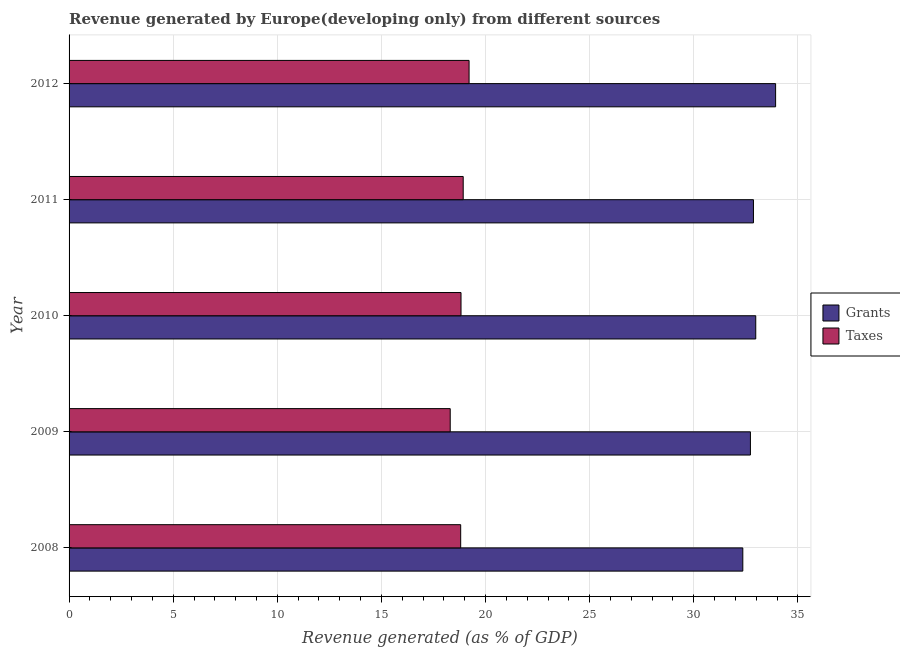How many different coloured bars are there?
Make the answer very short. 2. How many groups of bars are there?
Keep it short and to the point. 5. Are the number of bars per tick equal to the number of legend labels?
Give a very brief answer. Yes. How many bars are there on the 4th tick from the bottom?
Ensure brevity in your answer.  2. What is the label of the 5th group of bars from the top?
Make the answer very short. 2008. What is the revenue generated by taxes in 2012?
Ensure brevity in your answer.  19.21. Across all years, what is the maximum revenue generated by grants?
Your response must be concise. 33.93. Across all years, what is the minimum revenue generated by taxes?
Provide a succinct answer. 18.3. What is the total revenue generated by taxes in the graph?
Keep it short and to the point. 94.07. What is the difference between the revenue generated by taxes in 2008 and that in 2012?
Keep it short and to the point. -0.4. What is the difference between the revenue generated by grants in 2009 and the revenue generated by taxes in 2012?
Keep it short and to the point. 13.51. What is the average revenue generated by grants per year?
Your response must be concise. 32.97. In the year 2012, what is the difference between the revenue generated by taxes and revenue generated by grants?
Your response must be concise. -14.72. What is the ratio of the revenue generated by taxes in 2009 to that in 2012?
Provide a short and direct response. 0.95. What is the difference between the highest and the second highest revenue generated by taxes?
Ensure brevity in your answer.  0.28. What is the difference between the highest and the lowest revenue generated by taxes?
Provide a short and direct response. 0.91. In how many years, is the revenue generated by taxes greater than the average revenue generated by taxes taken over all years?
Offer a very short reply. 3. What does the 2nd bar from the top in 2009 represents?
Offer a terse response. Grants. What does the 2nd bar from the bottom in 2008 represents?
Offer a terse response. Taxes. How many years are there in the graph?
Offer a very short reply. 5. What is the difference between two consecutive major ticks on the X-axis?
Offer a terse response. 5. Where does the legend appear in the graph?
Keep it short and to the point. Center right. How many legend labels are there?
Provide a succinct answer. 2. How are the legend labels stacked?
Offer a very short reply. Vertical. What is the title of the graph?
Keep it short and to the point. Revenue generated by Europe(developing only) from different sources. Does "State government" appear as one of the legend labels in the graph?
Offer a terse response. No. What is the label or title of the X-axis?
Give a very brief answer. Revenue generated (as % of GDP). What is the Revenue generated (as % of GDP) in Grants in 2008?
Make the answer very short. 32.35. What is the Revenue generated (as % of GDP) of Taxes in 2008?
Offer a very short reply. 18.81. What is the Revenue generated (as % of GDP) in Grants in 2009?
Give a very brief answer. 32.72. What is the Revenue generated (as % of GDP) in Taxes in 2009?
Keep it short and to the point. 18.3. What is the Revenue generated (as % of GDP) of Grants in 2010?
Keep it short and to the point. 32.98. What is the Revenue generated (as % of GDP) in Taxes in 2010?
Your answer should be very brief. 18.82. What is the Revenue generated (as % of GDP) of Grants in 2011?
Your answer should be very brief. 32.87. What is the Revenue generated (as % of GDP) of Taxes in 2011?
Provide a succinct answer. 18.93. What is the Revenue generated (as % of GDP) of Grants in 2012?
Your answer should be very brief. 33.93. What is the Revenue generated (as % of GDP) in Taxes in 2012?
Offer a terse response. 19.21. Across all years, what is the maximum Revenue generated (as % of GDP) of Grants?
Provide a short and direct response. 33.93. Across all years, what is the maximum Revenue generated (as % of GDP) in Taxes?
Offer a very short reply. 19.21. Across all years, what is the minimum Revenue generated (as % of GDP) in Grants?
Make the answer very short. 32.35. Across all years, what is the minimum Revenue generated (as % of GDP) in Taxes?
Your answer should be compact. 18.3. What is the total Revenue generated (as % of GDP) of Grants in the graph?
Ensure brevity in your answer.  164.85. What is the total Revenue generated (as % of GDP) in Taxes in the graph?
Make the answer very short. 94.07. What is the difference between the Revenue generated (as % of GDP) in Grants in 2008 and that in 2009?
Your answer should be very brief. -0.37. What is the difference between the Revenue generated (as % of GDP) of Taxes in 2008 and that in 2009?
Keep it short and to the point. 0.5. What is the difference between the Revenue generated (as % of GDP) in Grants in 2008 and that in 2010?
Offer a terse response. -0.62. What is the difference between the Revenue generated (as % of GDP) in Taxes in 2008 and that in 2010?
Offer a very short reply. -0.02. What is the difference between the Revenue generated (as % of GDP) of Grants in 2008 and that in 2011?
Give a very brief answer. -0.51. What is the difference between the Revenue generated (as % of GDP) in Taxes in 2008 and that in 2011?
Offer a terse response. -0.12. What is the difference between the Revenue generated (as % of GDP) of Grants in 2008 and that in 2012?
Your answer should be compact. -1.57. What is the difference between the Revenue generated (as % of GDP) in Taxes in 2008 and that in 2012?
Your answer should be compact. -0.4. What is the difference between the Revenue generated (as % of GDP) of Grants in 2009 and that in 2010?
Provide a succinct answer. -0.26. What is the difference between the Revenue generated (as % of GDP) of Taxes in 2009 and that in 2010?
Give a very brief answer. -0.52. What is the difference between the Revenue generated (as % of GDP) in Grants in 2009 and that in 2011?
Your answer should be very brief. -0.15. What is the difference between the Revenue generated (as % of GDP) of Taxes in 2009 and that in 2011?
Give a very brief answer. -0.62. What is the difference between the Revenue generated (as % of GDP) of Grants in 2009 and that in 2012?
Your response must be concise. -1.21. What is the difference between the Revenue generated (as % of GDP) of Taxes in 2009 and that in 2012?
Provide a succinct answer. -0.91. What is the difference between the Revenue generated (as % of GDP) in Grants in 2010 and that in 2011?
Ensure brevity in your answer.  0.11. What is the difference between the Revenue generated (as % of GDP) in Taxes in 2010 and that in 2011?
Keep it short and to the point. -0.1. What is the difference between the Revenue generated (as % of GDP) in Grants in 2010 and that in 2012?
Give a very brief answer. -0.95. What is the difference between the Revenue generated (as % of GDP) in Taxes in 2010 and that in 2012?
Your answer should be very brief. -0.39. What is the difference between the Revenue generated (as % of GDP) of Grants in 2011 and that in 2012?
Offer a terse response. -1.06. What is the difference between the Revenue generated (as % of GDP) of Taxes in 2011 and that in 2012?
Offer a very short reply. -0.28. What is the difference between the Revenue generated (as % of GDP) in Grants in 2008 and the Revenue generated (as % of GDP) in Taxes in 2009?
Offer a very short reply. 14.05. What is the difference between the Revenue generated (as % of GDP) in Grants in 2008 and the Revenue generated (as % of GDP) in Taxes in 2010?
Provide a short and direct response. 13.53. What is the difference between the Revenue generated (as % of GDP) in Grants in 2008 and the Revenue generated (as % of GDP) in Taxes in 2011?
Provide a short and direct response. 13.43. What is the difference between the Revenue generated (as % of GDP) in Grants in 2008 and the Revenue generated (as % of GDP) in Taxes in 2012?
Give a very brief answer. 13.15. What is the difference between the Revenue generated (as % of GDP) in Grants in 2009 and the Revenue generated (as % of GDP) in Taxes in 2010?
Your answer should be very brief. 13.9. What is the difference between the Revenue generated (as % of GDP) in Grants in 2009 and the Revenue generated (as % of GDP) in Taxes in 2011?
Provide a short and direct response. 13.79. What is the difference between the Revenue generated (as % of GDP) of Grants in 2009 and the Revenue generated (as % of GDP) of Taxes in 2012?
Provide a succinct answer. 13.51. What is the difference between the Revenue generated (as % of GDP) in Grants in 2010 and the Revenue generated (as % of GDP) in Taxes in 2011?
Offer a very short reply. 14.05. What is the difference between the Revenue generated (as % of GDP) in Grants in 2010 and the Revenue generated (as % of GDP) in Taxes in 2012?
Offer a very short reply. 13.77. What is the difference between the Revenue generated (as % of GDP) of Grants in 2011 and the Revenue generated (as % of GDP) of Taxes in 2012?
Provide a short and direct response. 13.66. What is the average Revenue generated (as % of GDP) of Grants per year?
Give a very brief answer. 32.97. What is the average Revenue generated (as % of GDP) in Taxes per year?
Your answer should be compact. 18.81. In the year 2008, what is the difference between the Revenue generated (as % of GDP) in Grants and Revenue generated (as % of GDP) in Taxes?
Your answer should be compact. 13.55. In the year 2009, what is the difference between the Revenue generated (as % of GDP) of Grants and Revenue generated (as % of GDP) of Taxes?
Your response must be concise. 14.42. In the year 2010, what is the difference between the Revenue generated (as % of GDP) of Grants and Revenue generated (as % of GDP) of Taxes?
Make the answer very short. 14.15. In the year 2011, what is the difference between the Revenue generated (as % of GDP) of Grants and Revenue generated (as % of GDP) of Taxes?
Your response must be concise. 13.94. In the year 2012, what is the difference between the Revenue generated (as % of GDP) of Grants and Revenue generated (as % of GDP) of Taxes?
Ensure brevity in your answer.  14.72. What is the ratio of the Revenue generated (as % of GDP) of Grants in 2008 to that in 2009?
Give a very brief answer. 0.99. What is the ratio of the Revenue generated (as % of GDP) of Taxes in 2008 to that in 2009?
Make the answer very short. 1.03. What is the ratio of the Revenue generated (as % of GDP) of Grants in 2008 to that in 2010?
Keep it short and to the point. 0.98. What is the ratio of the Revenue generated (as % of GDP) of Taxes in 2008 to that in 2010?
Your answer should be compact. 1. What is the ratio of the Revenue generated (as % of GDP) in Grants in 2008 to that in 2011?
Provide a succinct answer. 0.98. What is the ratio of the Revenue generated (as % of GDP) of Grants in 2008 to that in 2012?
Make the answer very short. 0.95. What is the ratio of the Revenue generated (as % of GDP) in Taxes in 2008 to that in 2012?
Keep it short and to the point. 0.98. What is the ratio of the Revenue generated (as % of GDP) in Grants in 2009 to that in 2010?
Offer a very short reply. 0.99. What is the ratio of the Revenue generated (as % of GDP) in Taxes in 2009 to that in 2010?
Provide a short and direct response. 0.97. What is the ratio of the Revenue generated (as % of GDP) of Grants in 2009 to that in 2011?
Your answer should be compact. 1. What is the ratio of the Revenue generated (as % of GDP) in Taxes in 2009 to that in 2011?
Provide a short and direct response. 0.97. What is the ratio of the Revenue generated (as % of GDP) in Grants in 2009 to that in 2012?
Your response must be concise. 0.96. What is the ratio of the Revenue generated (as % of GDP) of Taxes in 2009 to that in 2012?
Your answer should be very brief. 0.95. What is the ratio of the Revenue generated (as % of GDP) of Grants in 2010 to that in 2011?
Provide a short and direct response. 1. What is the ratio of the Revenue generated (as % of GDP) of Grants in 2010 to that in 2012?
Provide a short and direct response. 0.97. What is the ratio of the Revenue generated (as % of GDP) in Taxes in 2010 to that in 2012?
Keep it short and to the point. 0.98. What is the ratio of the Revenue generated (as % of GDP) of Grants in 2011 to that in 2012?
Provide a succinct answer. 0.97. What is the difference between the highest and the second highest Revenue generated (as % of GDP) of Grants?
Make the answer very short. 0.95. What is the difference between the highest and the second highest Revenue generated (as % of GDP) in Taxes?
Give a very brief answer. 0.28. What is the difference between the highest and the lowest Revenue generated (as % of GDP) of Grants?
Keep it short and to the point. 1.57. What is the difference between the highest and the lowest Revenue generated (as % of GDP) of Taxes?
Keep it short and to the point. 0.91. 